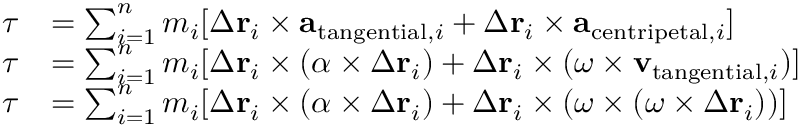<formula> <loc_0><loc_0><loc_500><loc_500>{ \begin{array} { r l } { \tau } & { = \sum _ { i = 1 } ^ { n } m _ { i } [ \Delta r _ { i } \times a _ { { t a n g e n t i a l } , i } + \Delta r _ { i } \times a _ { { c e n t r i p e t a l } , i } ] } \\ { \tau } & { = \sum _ { i = 1 } ^ { n } m _ { i } [ \Delta r _ { i } \times ( { \alpha } \times \Delta r _ { i } ) + \Delta r _ { i } \times ( { \omega } \times v _ { { t a n g e n t i a l } , i } ) ] } \\ { \tau } & { = \sum _ { i = 1 } ^ { n } m _ { i } [ \Delta r _ { i } \times ( { \alpha } \times \Delta r _ { i } ) + \Delta r _ { i } \times ( { \omega } \times ( { \omega } \times \Delta r _ { i } ) ) ] } \end{array} }</formula> 